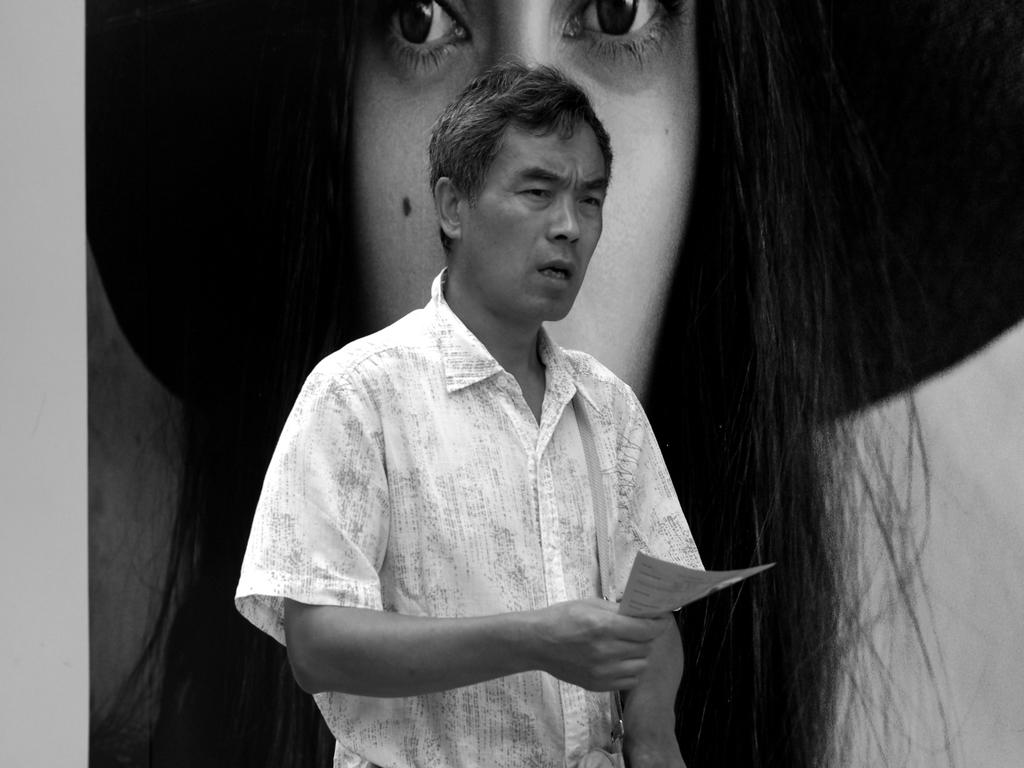What is the main subject in the foreground of the picture? There is a man in the foreground of the picture. What is the man holding in the picture? The man is holding a paper. What can be seen in the background of the picture? There is a poster in the background of the picture. What is depicted on the poster? The poster features a woman wearing a hat. What type of sound can be heard coming from the woman on the poster? There is no sound present in the image, as it is a static picture. Additionally, the woman on the poster is not a real person, so she cannot produce any sound. 